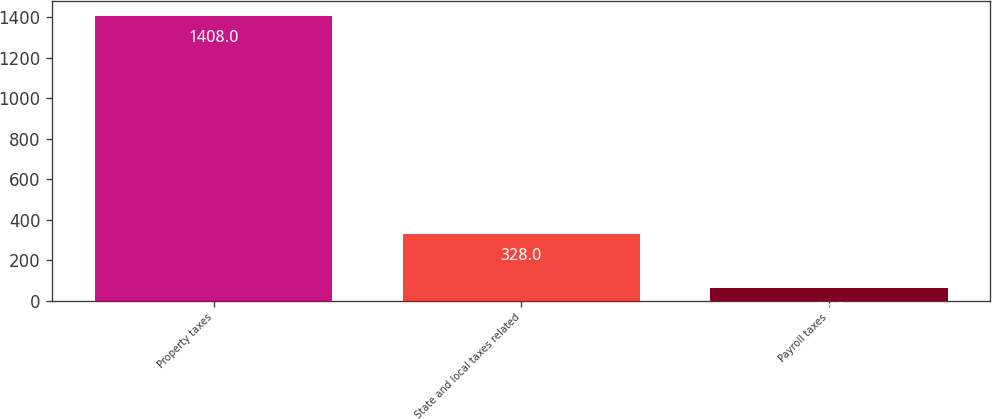Convert chart. <chart><loc_0><loc_0><loc_500><loc_500><bar_chart><fcel>Property taxes<fcel>State and local taxes related<fcel>Payroll taxes<nl><fcel>1408<fcel>328<fcel>63<nl></chart> 